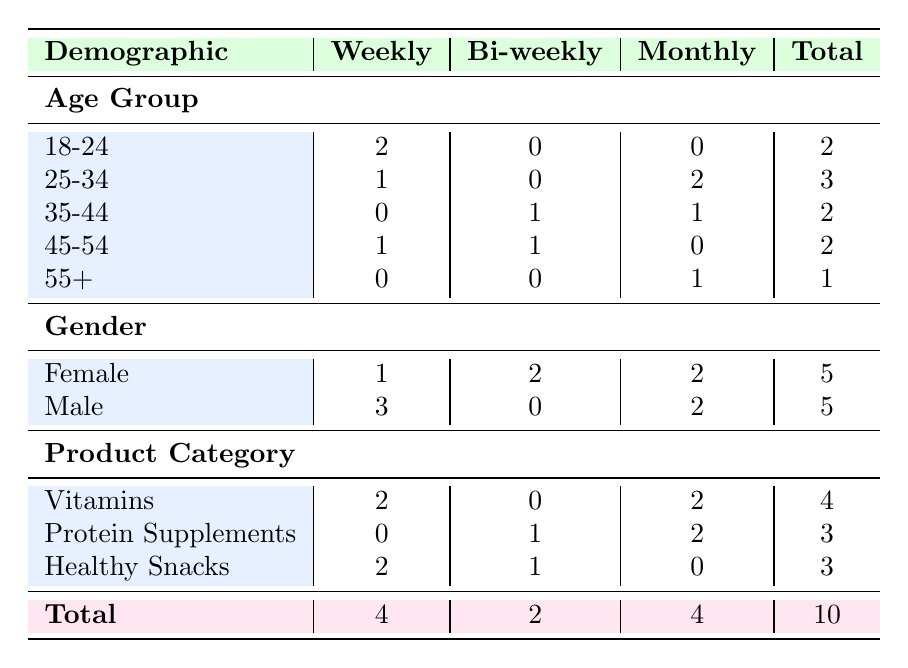What is the total number of customers who purchase products weekly? To find the answer, we look under the "Weekly" column and sum the counts for each demographic category: 2 from Age Group, 1 from Gender, and 3 from Product Category. We confirm that the total adds up to 4.
Answer: 4 Which age group has the highest purchase frequency of bi-weekly? In the "Bi-weekly" column, we examine the counts across age groups. The maximum value is 1 for both the 35-44 and 45-54 age groups, indicating they share the highest frequency of bi-weekly purchases.
Answer: 35-44 and 45-54 Is there any demographic group where all customers have made purchases on a monthly basis? Reviewing the "Monthly" column shows age groups with counts: 0 (18-24), 2 (25-34), 1 (35-44), and 0 (45-54) and 1 (55+). Since no age group has all members purchasing monthly, the answer is no.
Answer: No What percentage of female customers purchase vitamins weekly? Female customers have a total of 5 purchases, out of which 1 purchase is on a weekly basis for vitamins. The percentage is calculated as (1/5) * 100 = 20%.
Answer: 20% Which product category has the highest overall purchase frequency, and how many total purchases did it receive? Summing the total purchases from each product category gives: Vitamins (4), Protein Supplements (3), and Healthy Snacks (3). Since Vitamins has the highest at 4 total purchases, it’s the answer.
Answer: Vitamins, 4 How many more males purchase on a weekly basis compared to females? From the "Weekly" column, Males have 3 purchases while Females have 1. The difference is 3 - 1 = 2 more males purchasing weekly compared to females.
Answer: 2 Is the number of purchases for Protein Supplements greater than that for Healthy Snacks? By reviewing the totals for each product category, Protein Supplements have 3 purchases and Healthy Snacks have 3 purchases, leading to the conclusion that the counts are equal.
Answer: No What is the total number of customers over 35 years old who purchase products monthly? We count customers in the 35-44 and 55+ age groups under the "Monthly" column, which gives 1 from the 35-44 age group and 1 from the 55+ age group, summing to 2 total customers over 35.
Answer: 2 